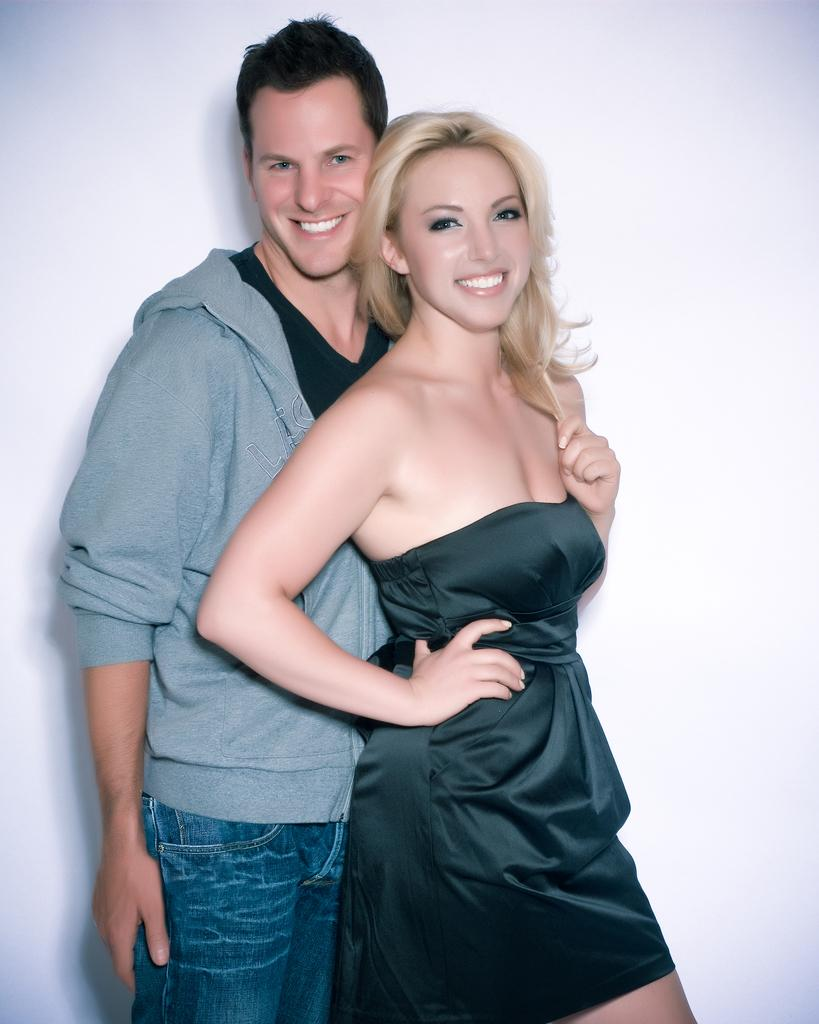How many people are in the image? There are two people in the image. What are the two people doing in the image? The two people are standing. What expressions do the two people have in the image? The two people are smiling. What type of paste is being used by the people in the image? There is no paste present in the image; the two people are simply standing and smiling. 